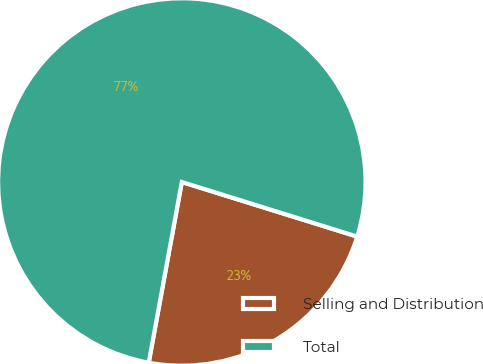Convert chart to OTSL. <chart><loc_0><loc_0><loc_500><loc_500><pie_chart><fcel>Selling and Distribution<fcel>Total<nl><fcel>23.08%<fcel>76.92%<nl></chart> 